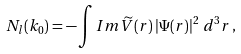Convert formula to latex. <formula><loc_0><loc_0><loc_500><loc_500>N _ { l } ( { k _ { 0 } } ) = - \int I m \widetilde { V } ( { r } ) \left | \Psi ( { r } ) \right | ^ { 2 } \, d ^ { 3 } r \, ,</formula> 